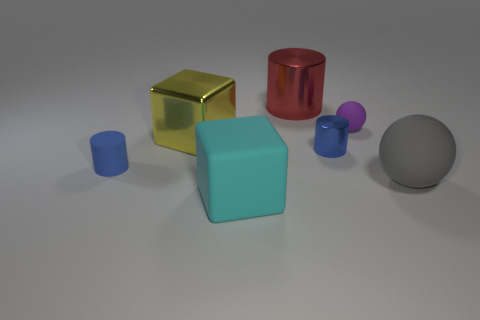Subtract all metal cylinders. How many cylinders are left? 1 Subtract all cyan cubes. How many blue cylinders are left? 2 Add 2 yellow shiny objects. How many objects exist? 9 Subtract all purple spheres. How many spheres are left? 1 Subtract 1 blocks. How many blocks are left? 1 Subtract 0 green cubes. How many objects are left? 7 Subtract all blocks. How many objects are left? 5 Subtract all red balls. Subtract all yellow cubes. How many balls are left? 2 Subtract all large red shiny balls. Subtract all big yellow metal things. How many objects are left? 6 Add 1 tiny shiny objects. How many tiny shiny objects are left? 2 